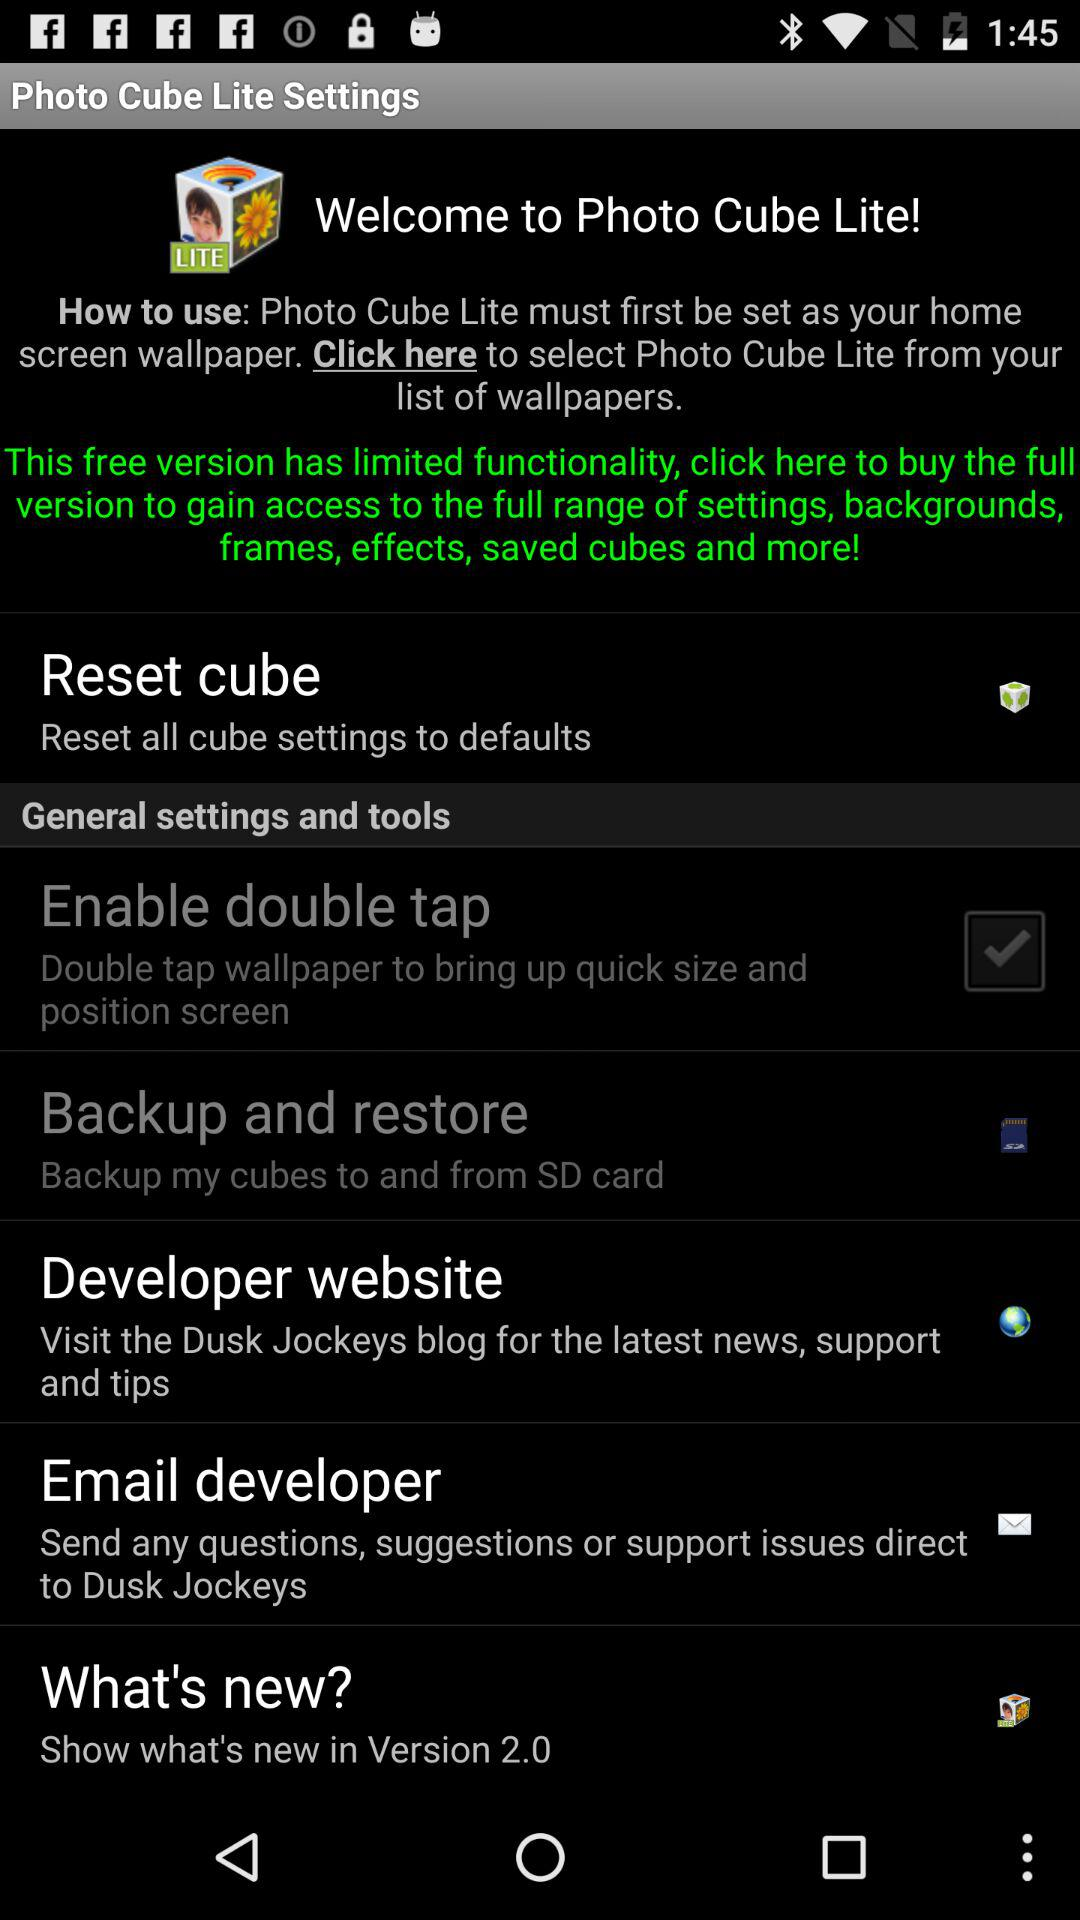What is the status of the "Enable double tap"? The status is "on". 